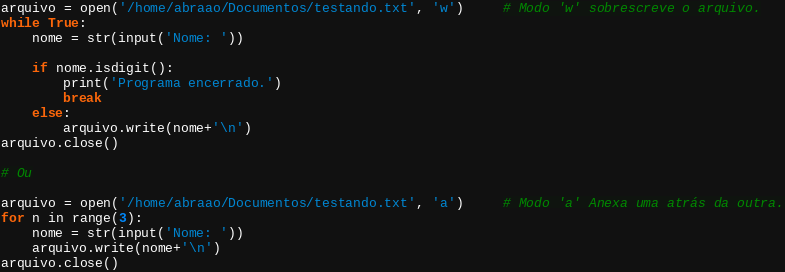Convert code to text. <code><loc_0><loc_0><loc_500><loc_500><_Python_>arquivo = open('/home/abraao/Documentos/testando.txt', 'w')     # Modo 'w' sobrescreve o arquivo.
while True:
    nome = str(input('Nome: '))

    if nome.isdigit():
        print('Programa encerrado.')
        break
    else:
        arquivo.write(nome+'\n')
arquivo.close()

# Ou

arquivo = open('/home/abraao/Documentos/testando.txt', 'a')     # Modo 'a' Anexa uma atrás da outra.
for n in range(3):
    nome = str(input('Nome: '))
    arquivo.write(nome+'\n')
arquivo.close()
</code> 